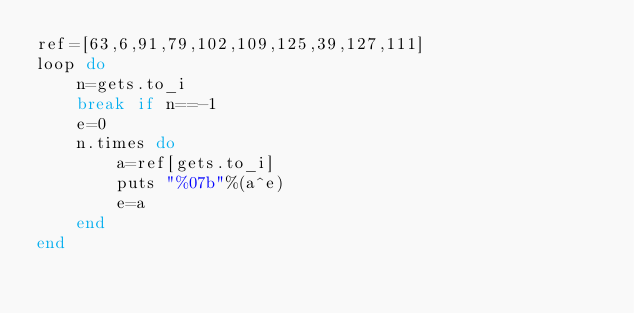<code> <loc_0><loc_0><loc_500><loc_500><_Ruby_>ref=[63,6,91,79,102,109,125,39,127,111]
loop do
	n=gets.to_i
	break if n==-1
	e=0
	n.times do
		a=ref[gets.to_i]
		puts "%07b"%(a^e)
		e=a
	end
end</code> 